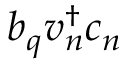<formula> <loc_0><loc_0><loc_500><loc_500>b _ { q } v _ { n } ^ { \dagger } c _ { n }</formula> 